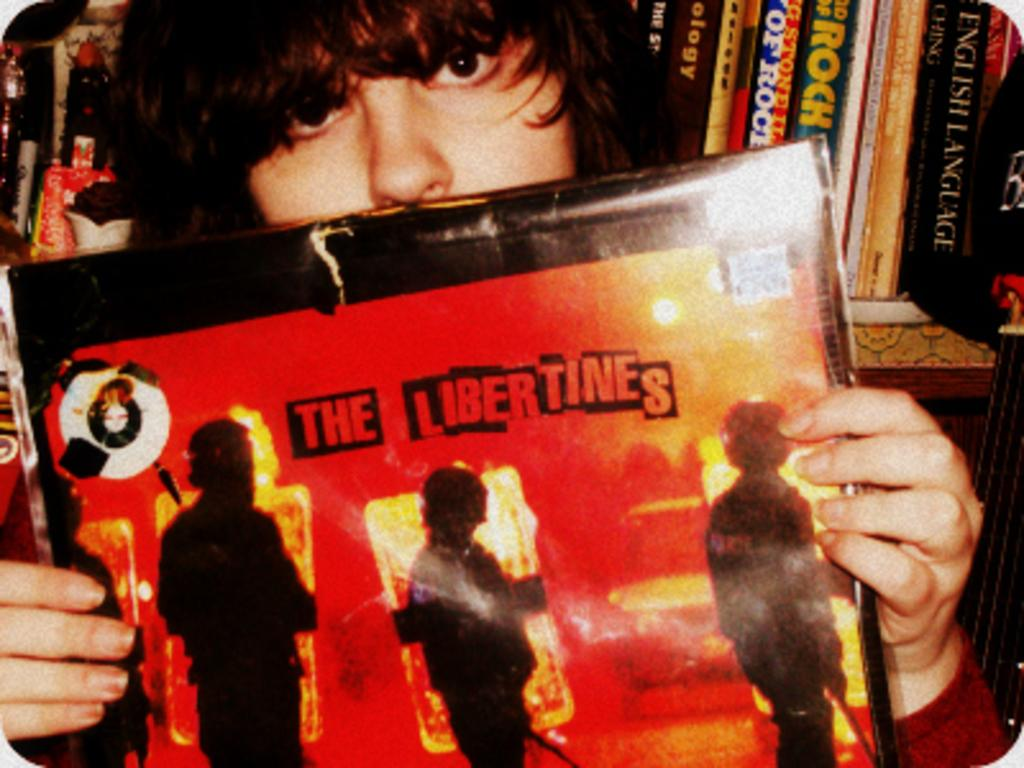What is the main subject of the image? There is a person in the image. What is the person doing in the image? The person is holding a board with his hands. Are there any other objects visible in the image? Yes, there are books in the top right of the image. What type of cracker is the person eating in the image? There is no cracker present in the image; the person is holding a board with his hands. Can you tell me the color of the locket the person is wearing in the image? There is no locket visible in the image; the person is holding a board with his hands. 